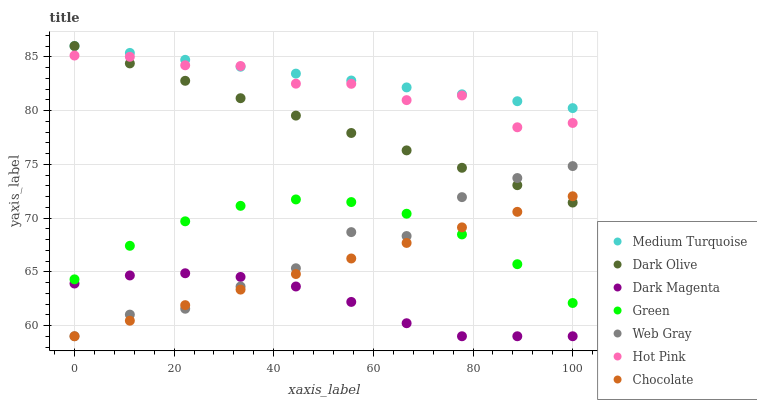Does Dark Magenta have the minimum area under the curve?
Answer yes or no. Yes. Does Medium Turquoise have the maximum area under the curve?
Answer yes or no. Yes. Does Dark Olive have the minimum area under the curve?
Answer yes or no. No. Does Dark Olive have the maximum area under the curve?
Answer yes or no. No. Is Dark Olive the smoothest?
Answer yes or no. Yes. Is Web Gray the roughest?
Answer yes or no. Yes. Is Dark Magenta the smoothest?
Answer yes or no. No. Is Dark Magenta the roughest?
Answer yes or no. No. Does Web Gray have the lowest value?
Answer yes or no. Yes. Does Dark Olive have the lowest value?
Answer yes or no. No. Does Medium Turquoise have the highest value?
Answer yes or no. Yes. Does Dark Magenta have the highest value?
Answer yes or no. No. Is Dark Magenta less than Hot Pink?
Answer yes or no. Yes. Is Hot Pink greater than Green?
Answer yes or no. Yes. Does Dark Olive intersect Hot Pink?
Answer yes or no. Yes. Is Dark Olive less than Hot Pink?
Answer yes or no. No. Is Dark Olive greater than Hot Pink?
Answer yes or no. No. Does Dark Magenta intersect Hot Pink?
Answer yes or no. No. 